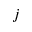Convert formula to latex. <formula><loc_0><loc_0><loc_500><loc_500>j</formula> 